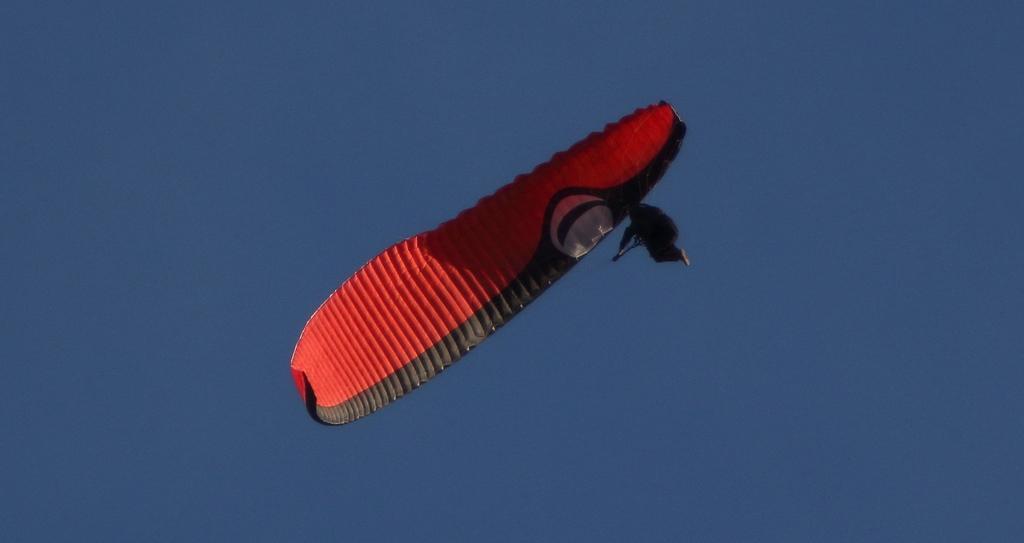Please provide a concise description of this image. In this image we can able to see a person is flying in the sky with the help of a parachute, which is red and black in color. 